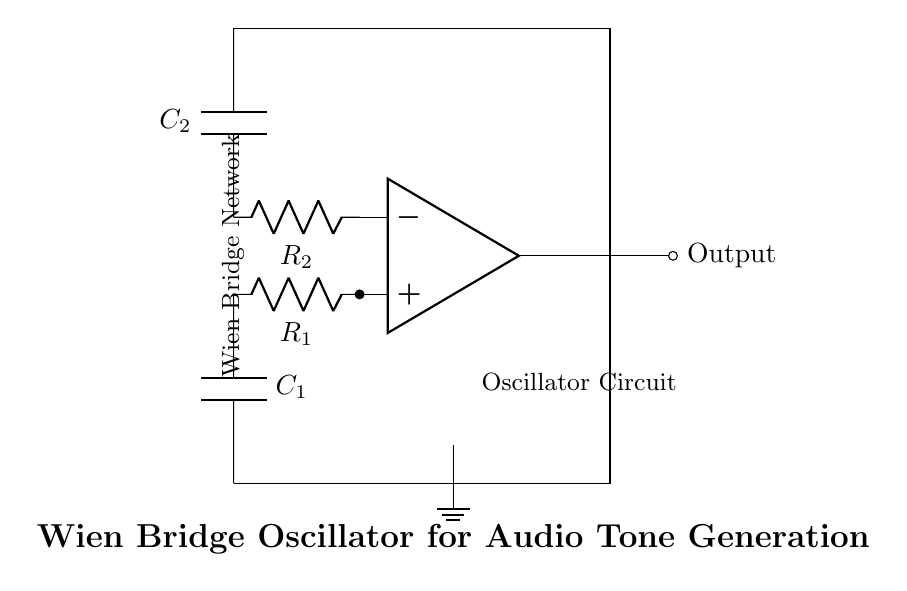What type of oscillator is this circuit? The circuit diagram depicts a Wien Bridge Oscillator, which is typically used for generating audio frequencies. This can be identified by its specific arrangement of resistor and capacitor components forming a bridge network.
Answer: Wien Bridge Oscillator What are the component values for R1 and R2? In the circuit diagram, resistor values are usually chosen based on desired frequency; however, they are not explicitly labeled in the diagram provided. Typically, R1 and R2 can be assumed to be equal for oscillation to occur.
Answer: Not specified What is the function of the capacitors in this circuit? The capacitors, C1 and C2, are part of the frequency-stabilizing components of the Wien Bridge circuit. They determine the frequency of oscillation in conjunction with resistors R1 and R2 through the timing characteristics of the RC network.
Answer: Frequency stabilization Which configuration does this circuit's feedback network take? The feedback network in this Wien Bridge Oscillator is a positive feedback loop formed by the path connecting the op-amp output back to the circuit. This specific feedback is necessary for sustained oscillation.
Answer: Positive feedback How does the output signal relate to the input signal? The output signal is an amplified version of the oscillations caused by the feedback mechanism in the Wien Bridge Oscillator, resulting in a sinusoidal waveform at the output. This relationship is foundational in audio tone generation.
Answer: Amplified sinusoidal waveform What role does the op-amp play in this circuit? The operational amplifier (op-amp) serves as the active element that provides the necessary gain to support oscillations. It detects the phase and gain conditions in feedback to maintain continuous oscillation.
Answer: Provides gain for oscillation 